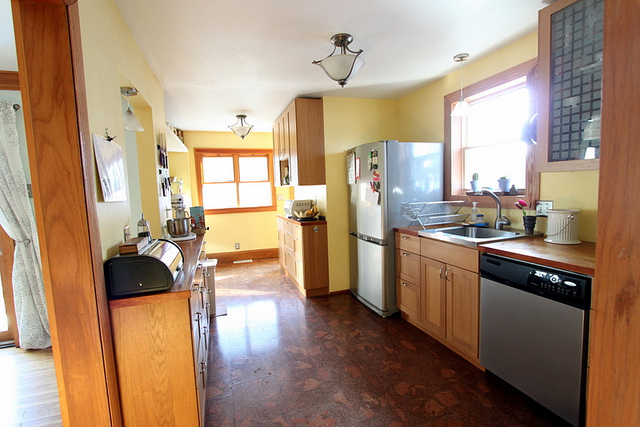What type of storage options are visible in this kitchen? The kitchen boasts ample storage with wooden cabinets and drawers, both above and below the countertop, providing plenty of space to organize kitchenware and essentials. 